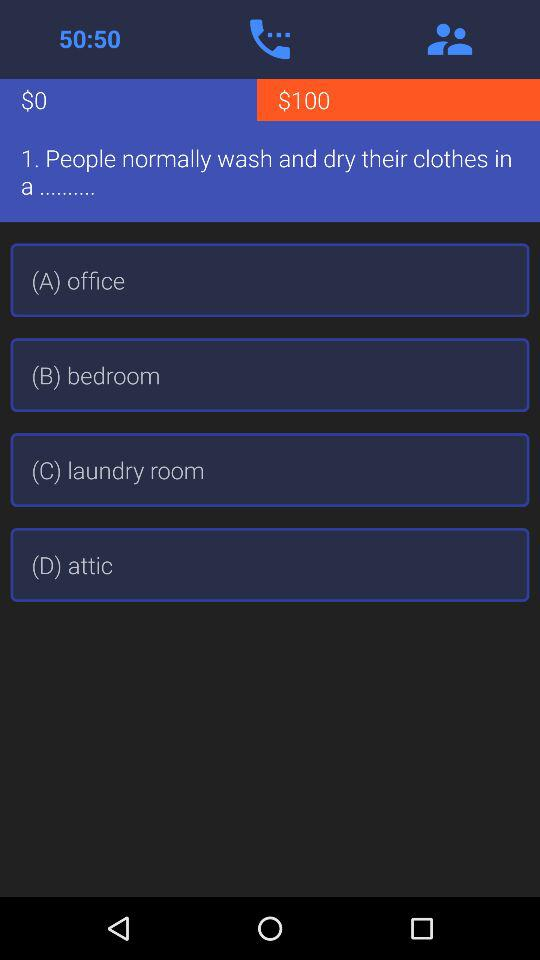What is the winning amount for this question? The winning amount is $100. 